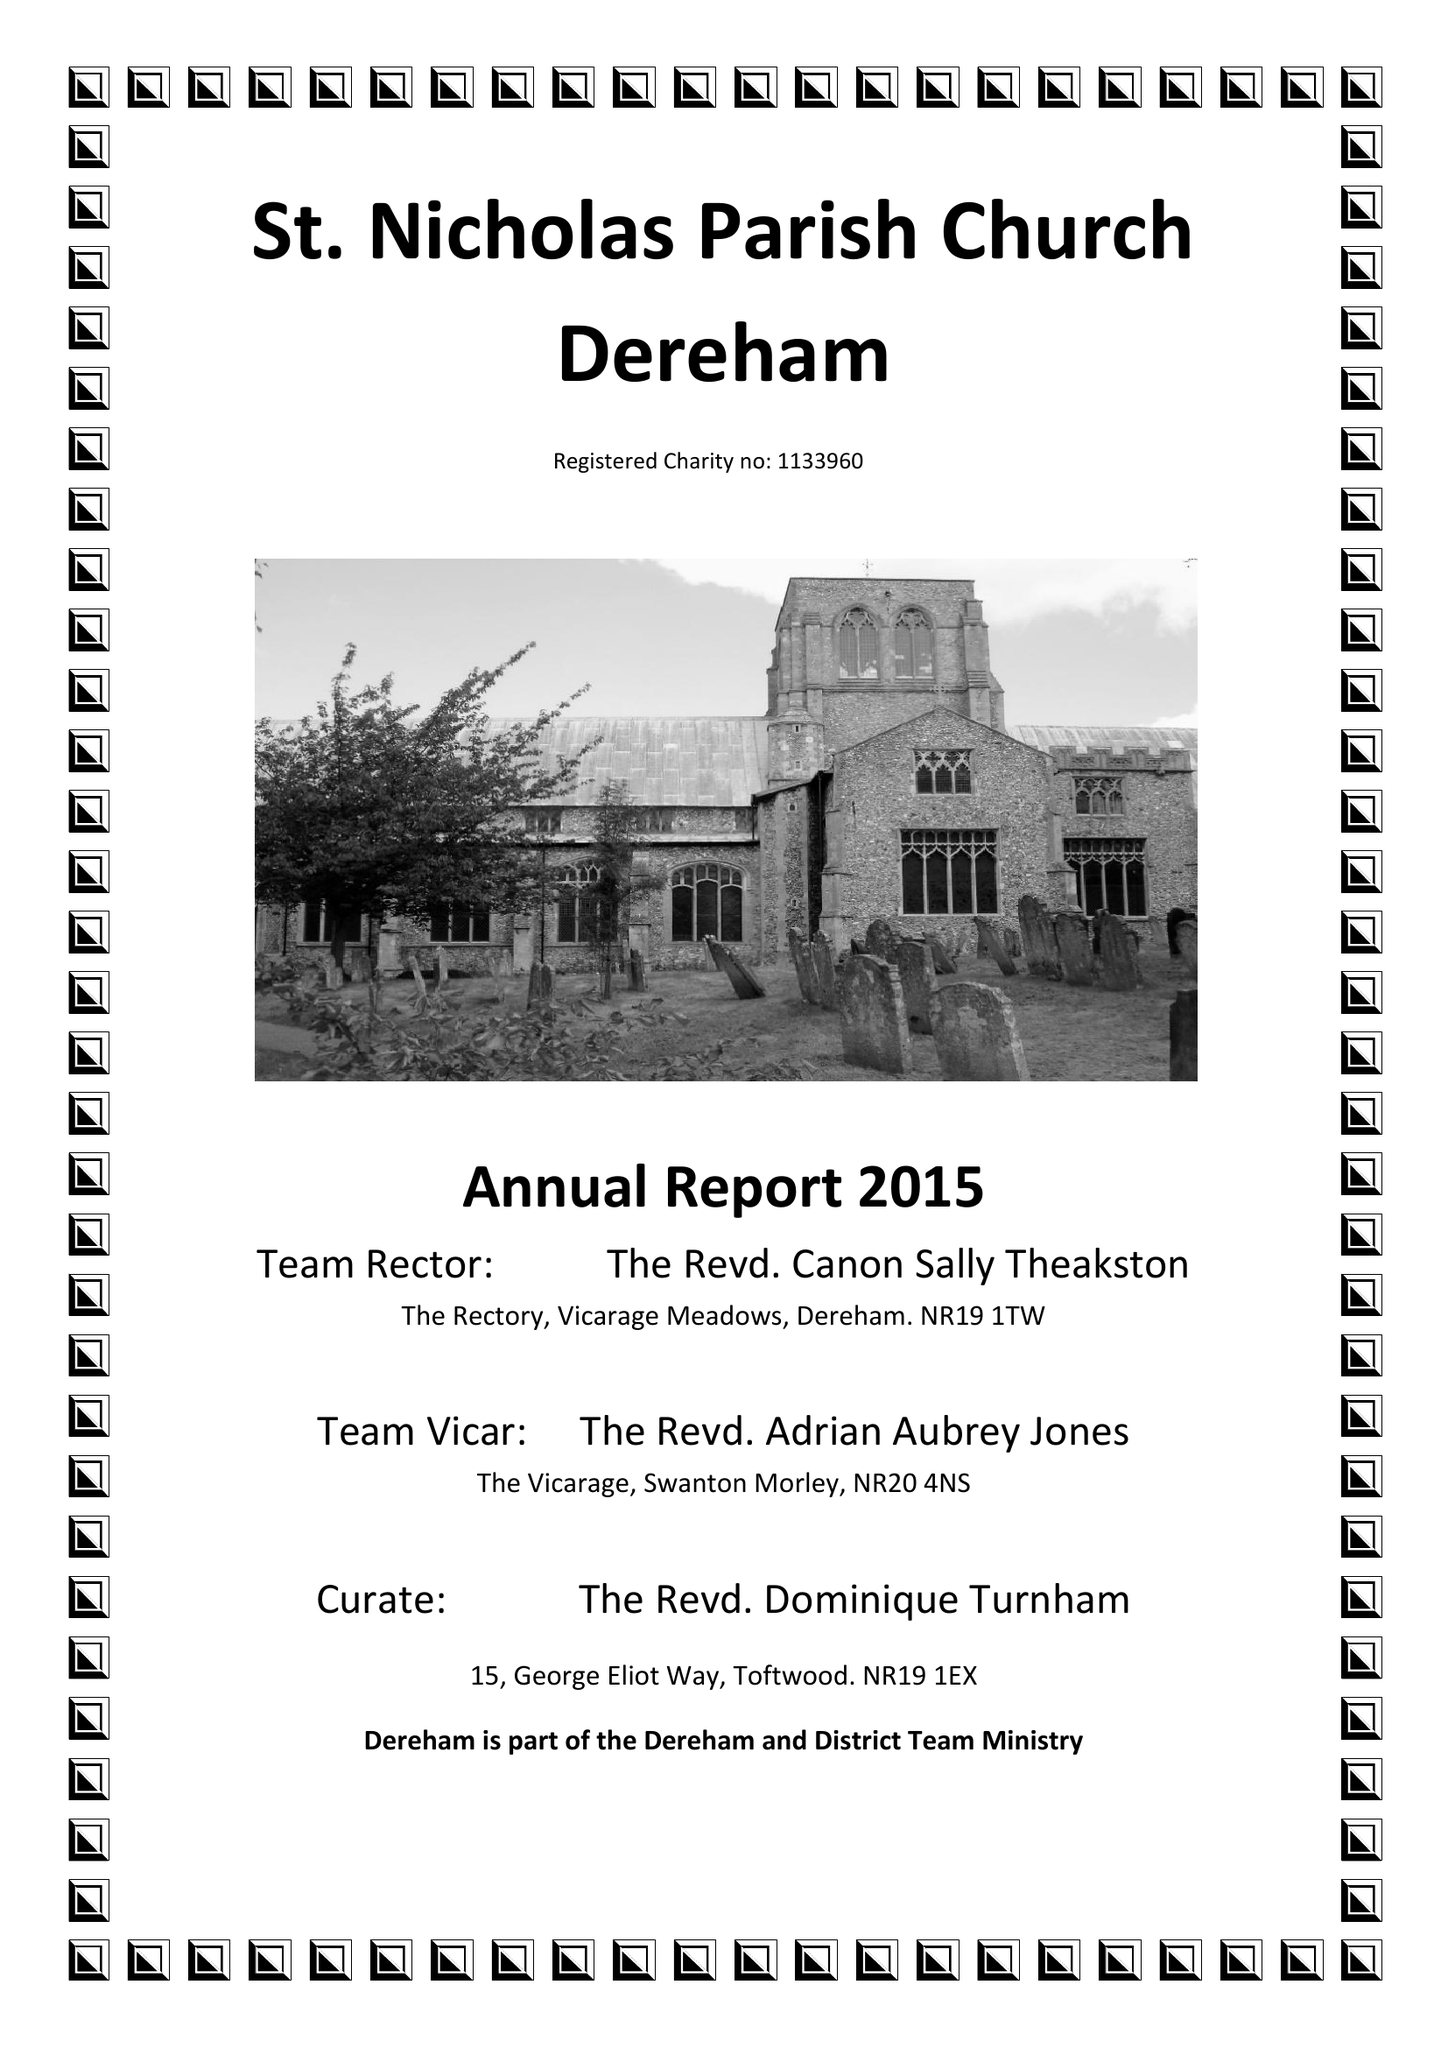What is the value for the charity_number?
Answer the question using a single word or phrase. 1133960 